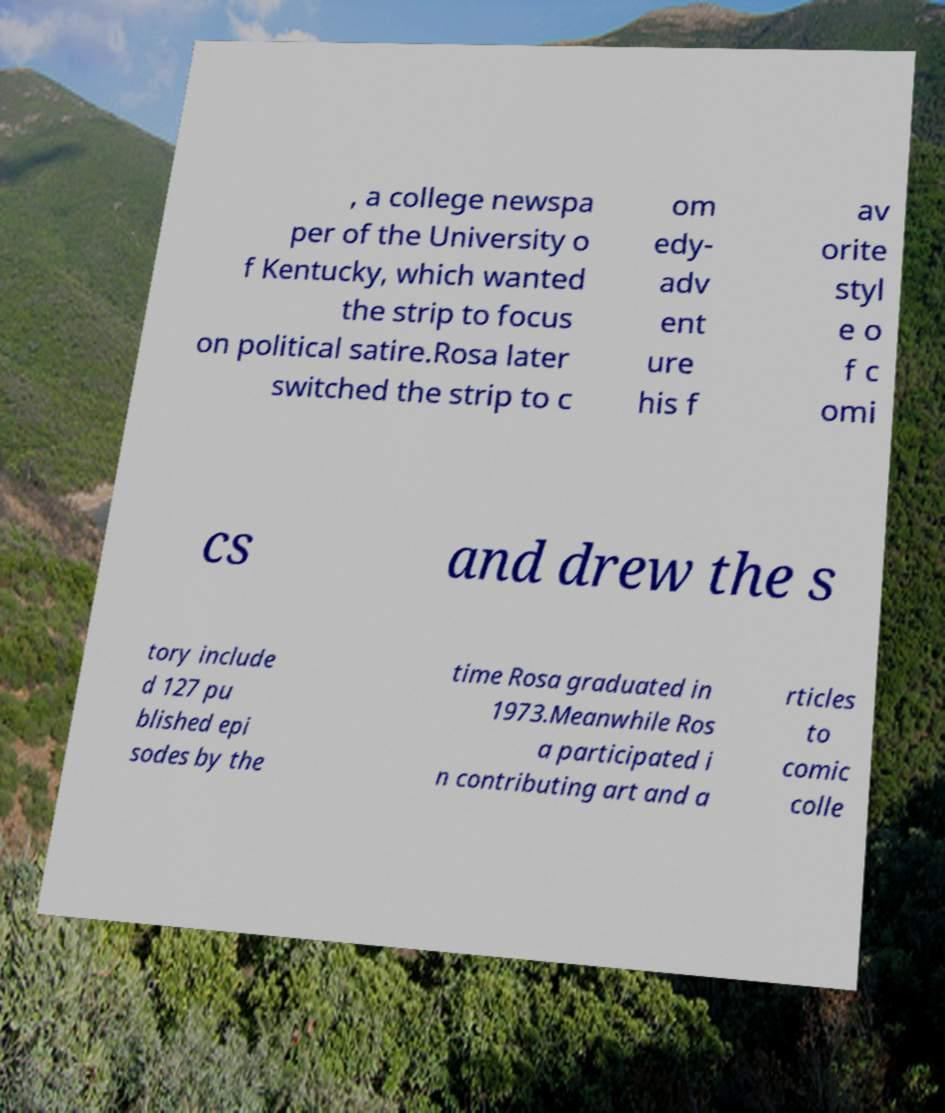Could you assist in decoding the text presented in this image and type it out clearly? , a college newspa per of the University o f Kentucky, which wanted the strip to focus on political satire.Rosa later switched the strip to c om edy- adv ent ure his f av orite styl e o f c omi cs and drew the s tory include d 127 pu blished epi sodes by the time Rosa graduated in 1973.Meanwhile Ros a participated i n contributing art and a rticles to comic colle 